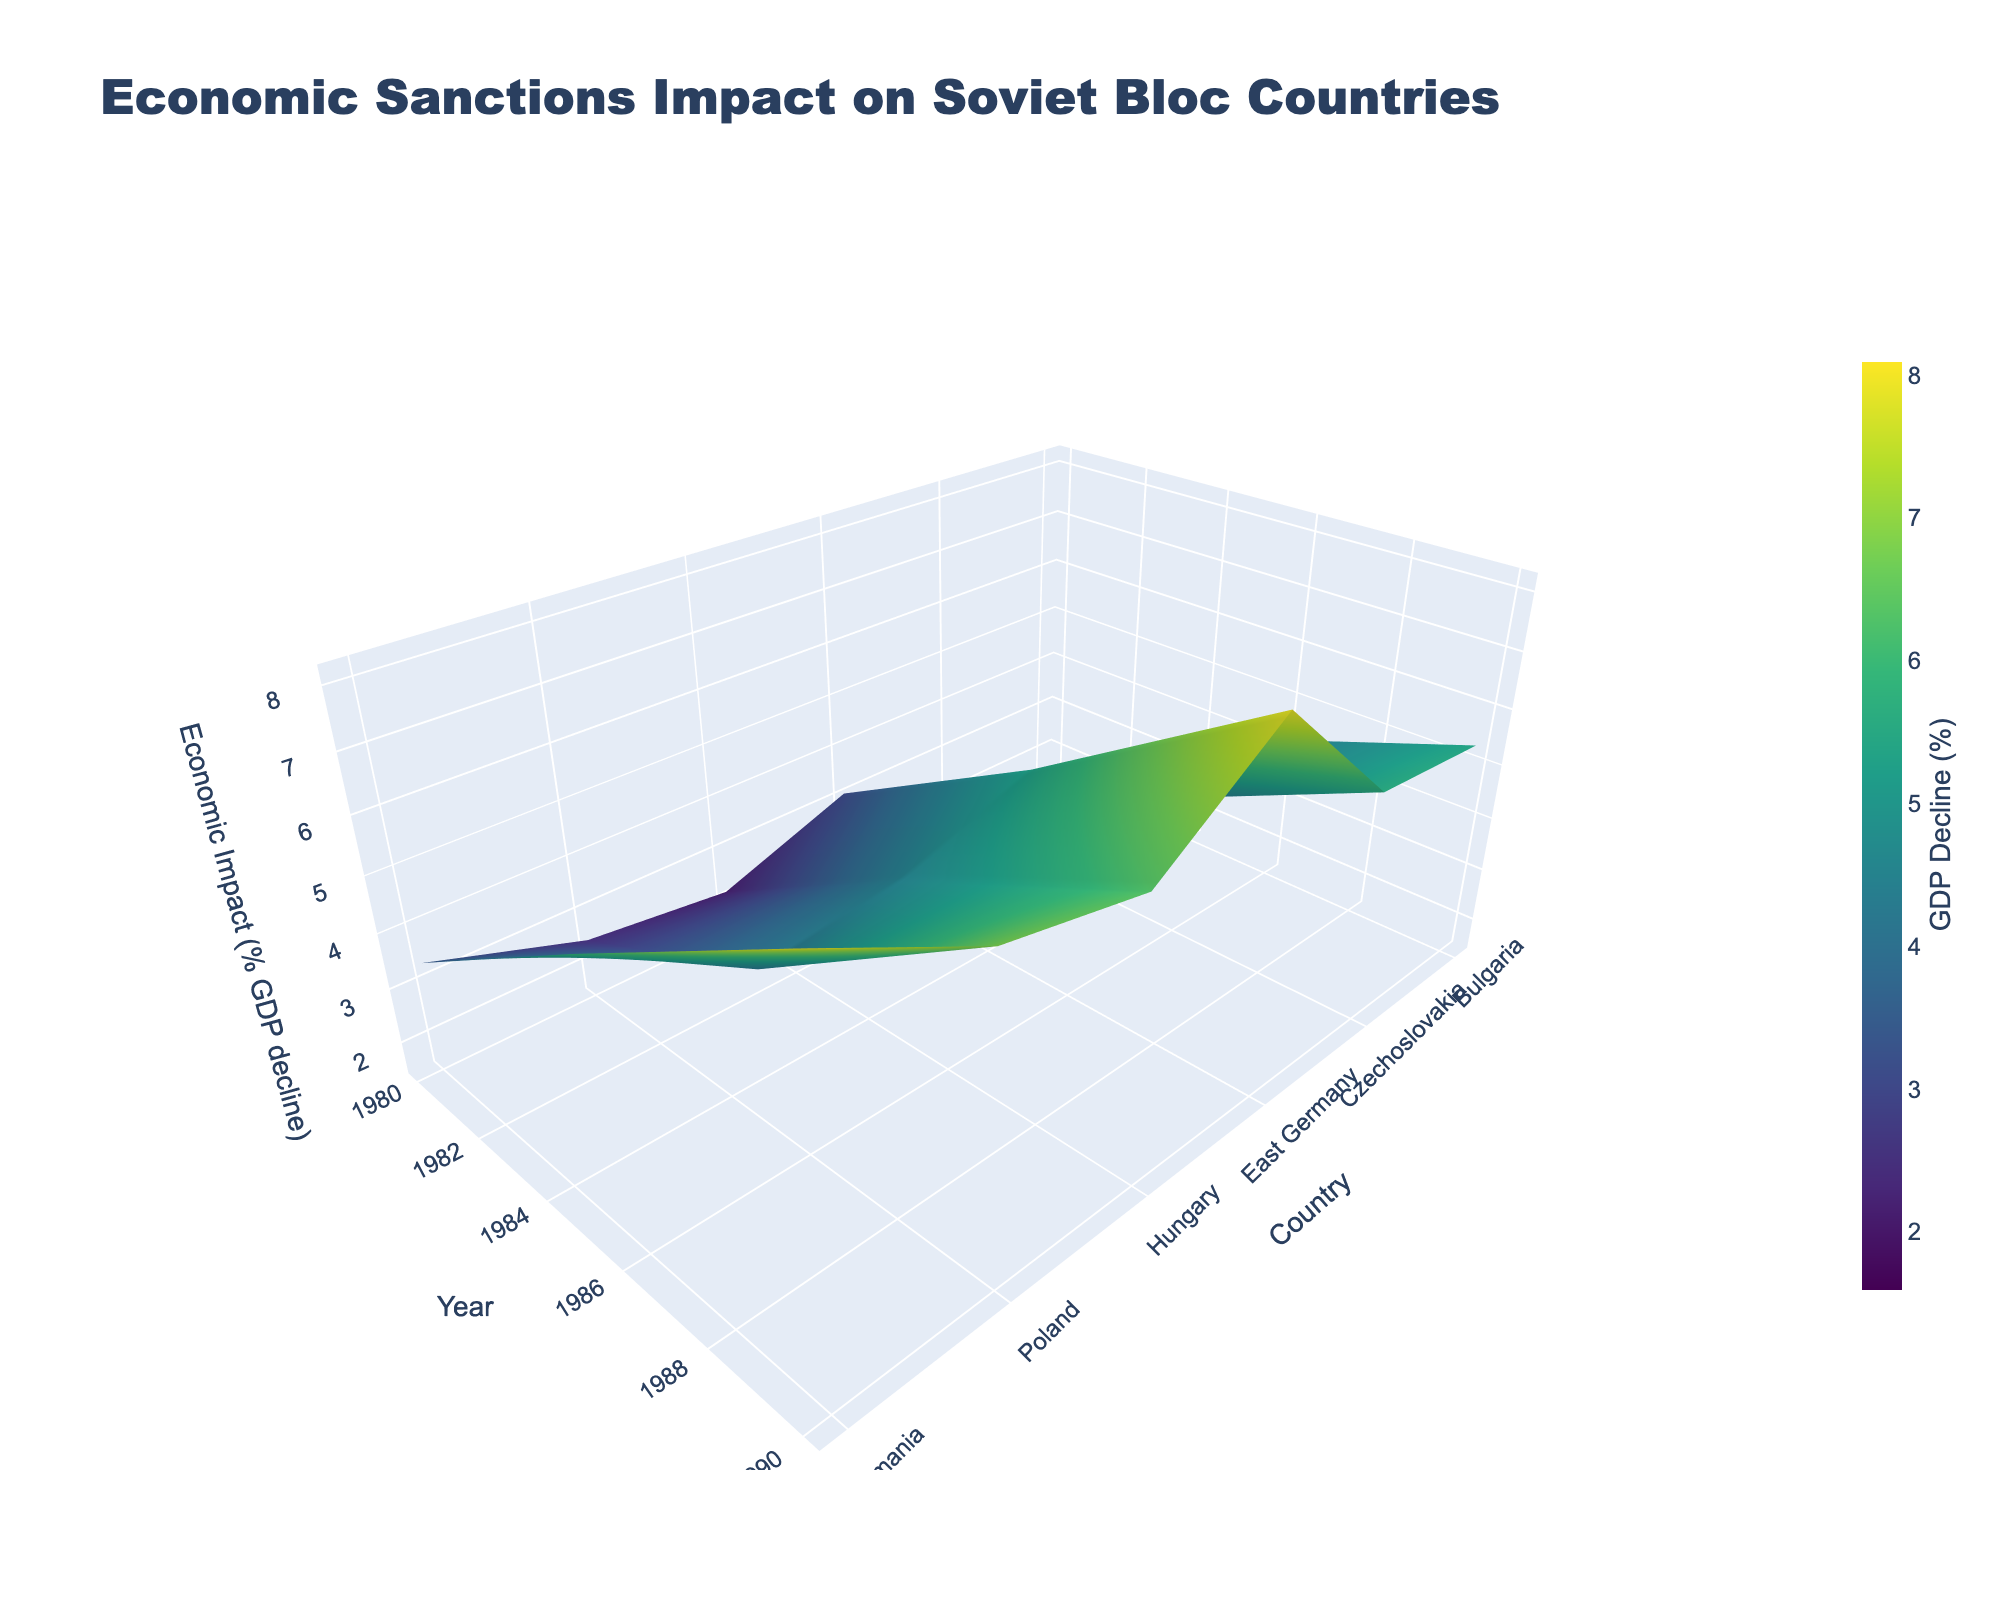What is the title of the figure? The title is located at the top of the figure and generally provides an overall description of the data being presented. By referring to this, one can easily find the exact text used.
Answer: Economic Sanctions Impact on Soviet Bloc Countries Which country experienced the highest percentage decline in GDP impact in 1990? To determine this, one needs to look along the 1990 tick on the y-axis and then find the highest elevation point on the z-axis (GDP decline) for that year. Given the color-coding, dark areas generally indicate greater impact.
Answer: Romania How did the economic impact on Hungary change from 1980 to 1990? To find this, observe Hungary's data points from 1980 to 1990 on the x-axis and note the changes in the z-axis values (GDP decline).
Answer: Increased from 2.2% to 6.3% Which year shows the steepest overall increase in economic impact across all countries? To answer this, compare the z-axis values from one year to the next for all countries. Look for the largest overall change in elevation between consecutive years on the figure.
Answer: From 1985 to 1990 What was the average GDP decline for Bulgaria from 1980 to 1990? First, identify the GDP decline values for Bulgaria for each year (1980: 1.6%, 1985: 3.9%, 1990: 5.4%). Then calculate the average of these values.
Answer: 3.63% Compare the economic impact on East Germany and Czechoslovakia in 1985. Which had a greater impact? Examine the z-axis values for both East Germany and Czechoslovakia in 1985. The country with the higher elevation on the z-axis had a greater impact.
Answer: East Germany What trend do you observe for Poland's economic impact from 1980 to 1990? Look at Poland's data points across the given years and note the trend by observing the changes in the z-axis values.
Answer: Consistent increase Among Poland, Romania, and Bulgaria, which country had the smallest GDP decline in 1985? Check the z-axis values for 1985 for Poland, Romania, and Bulgaria and determine which value is the smallest.
Answer: Bulgaria How does the 1985 GDP decline compare between Hungary and Poland? Evaluate the z-axis values for both Hungary and Poland in 1985 and compare them to see which country had the higher decline.
Answer: Poland had a higher decline What is the range of GDP decline percentages for Czechoslovakia across the entire period? Identify the minimum and maximum z-axis values for Czechoslovakia across all years (1980: 1.8%, 1985: 3.7%, 1990: 5.6%), then calculate the range (maximum - minimum).
Answer: 3.8% 